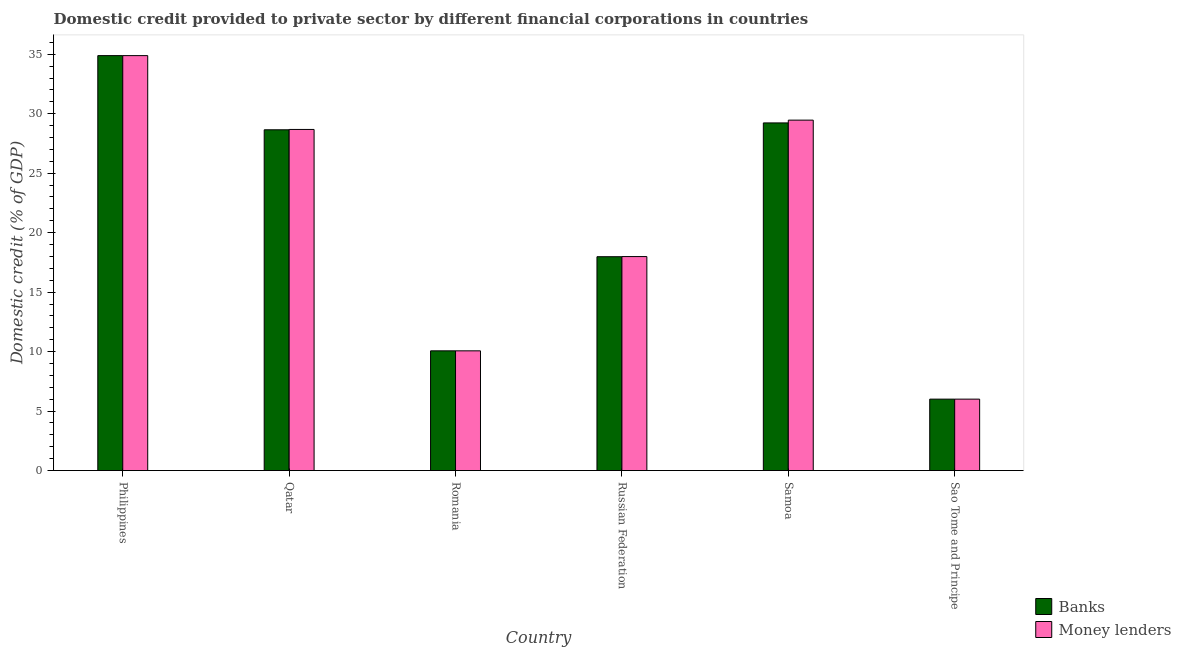What is the label of the 4th group of bars from the left?
Your answer should be compact. Russian Federation. In how many cases, is the number of bars for a given country not equal to the number of legend labels?
Ensure brevity in your answer.  0. What is the domestic credit provided by banks in Philippines?
Keep it short and to the point. 34.88. Across all countries, what is the maximum domestic credit provided by money lenders?
Your answer should be very brief. 34.88. Across all countries, what is the minimum domestic credit provided by banks?
Ensure brevity in your answer.  6.01. In which country was the domestic credit provided by banks maximum?
Make the answer very short. Philippines. In which country was the domestic credit provided by money lenders minimum?
Your answer should be very brief. Sao Tome and Principe. What is the total domestic credit provided by banks in the graph?
Keep it short and to the point. 126.81. What is the difference between the domestic credit provided by money lenders in Samoa and that in Sao Tome and Principe?
Offer a terse response. 23.46. What is the difference between the domestic credit provided by money lenders in Samoa and the domestic credit provided by banks in Romania?
Your answer should be compact. 19.4. What is the average domestic credit provided by banks per country?
Ensure brevity in your answer.  21.14. What is the difference between the domestic credit provided by banks and domestic credit provided by money lenders in Russian Federation?
Your answer should be compact. -0.01. In how many countries, is the domestic credit provided by money lenders greater than 22 %?
Your response must be concise. 3. What is the ratio of the domestic credit provided by money lenders in Philippines to that in Romania?
Your answer should be compact. 3.47. Is the domestic credit provided by money lenders in Philippines less than that in Romania?
Offer a terse response. No. What is the difference between the highest and the second highest domestic credit provided by money lenders?
Provide a short and direct response. 5.42. What is the difference between the highest and the lowest domestic credit provided by banks?
Your answer should be compact. 28.88. In how many countries, is the domestic credit provided by money lenders greater than the average domestic credit provided by money lenders taken over all countries?
Make the answer very short. 3. What does the 2nd bar from the left in Romania represents?
Keep it short and to the point. Money lenders. What does the 1st bar from the right in Russian Federation represents?
Your answer should be very brief. Money lenders. Are all the bars in the graph horizontal?
Provide a short and direct response. No. How many countries are there in the graph?
Your answer should be very brief. 6. What is the difference between two consecutive major ticks on the Y-axis?
Provide a short and direct response. 5. Are the values on the major ticks of Y-axis written in scientific E-notation?
Make the answer very short. No. Does the graph contain any zero values?
Your response must be concise. No. How many legend labels are there?
Keep it short and to the point. 2. How are the legend labels stacked?
Keep it short and to the point. Vertical. What is the title of the graph?
Offer a very short reply. Domestic credit provided to private sector by different financial corporations in countries. Does "Private funds" appear as one of the legend labels in the graph?
Provide a succinct answer. No. What is the label or title of the Y-axis?
Your answer should be compact. Domestic credit (% of GDP). What is the Domestic credit (% of GDP) of Banks in Philippines?
Ensure brevity in your answer.  34.88. What is the Domestic credit (% of GDP) of Money lenders in Philippines?
Your answer should be compact. 34.88. What is the Domestic credit (% of GDP) in Banks in Qatar?
Your response must be concise. 28.65. What is the Domestic credit (% of GDP) of Money lenders in Qatar?
Your answer should be compact. 28.68. What is the Domestic credit (% of GDP) of Banks in Romania?
Offer a terse response. 10.07. What is the Domestic credit (% of GDP) in Money lenders in Romania?
Your response must be concise. 10.07. What is the Domestic credit (% of GDP) in Banks in Russian Federation?
Your response must be concise. 17.98. What is the Domestic credit (% of GDP) of Money lenders in Russian Federation?
Provide a succinct answer. 17.99. What is the Domestic credit (% of GDP) of Banks in Samoa?
Provide a short and direct response. 29.23. What is the Domestic credit (% of GDP) of Money lenders in Samoa?
Offer a very short reply. 29.46. What is the Domestic credit (% of GDP) in Banks in Sao Tome and Principe?
Your answer should be compact. 6.01. What is the Domestic credit (% of GDP) in Money lenders in Sao Tome and Principe?
Give a very brief answer. 6.01. Across all countries, what is the maximum Domestic credit (% of GDP) of Banks?
Ensure brevity in your answer.  34.88. Across all countries, what is the maximum Domestic credit (% of GDP) in Money lenders?
Provide a short and direct response. 34.88. Across all countries, what is the minimum Domestic credit (% of GDP) of Banks?
Your answer should be compact. 6.01. Across all countries, what is the minimum Domestic credit (% of GDP) of Money lenders?
Ensure brevity in your answer.  6.01. What is the total Domestic credit (% of GDP) in Banks in the graph?
Provide a succinct answer. 126.81. What is the total Domestic credit (% of GDP) of Money lenders in the graph?
Give a very brief answer. 127.09. What is the difference between the Domestic credit (% of GDP) of Banks in Philippines and that in Qatar?
Your answer should be very brief. 6.24. What is the difference between the Domestic credit (% of GDP) of Money lenders in Philippines and that in Qatar?
Offer a very short reply. 6.21. What is the difference between the Domestic credit (% of GDP) in Banks in Philippines and that in Romania?
Offer a very short reply. 24.82. What is the difference between the Domestic credit (% of GDP) in Money lenders in Philippines and that in Romania?
Provide a succinct answer. 24.82. What is the difference between the Domestic credit (% of GDP) of Banks in Philippines and that in Russian Federation?
Make the answer very short. 16.91. What is the difference between the Domestic credit (% of GDP) in Money lenders in Philippines and that in Russian Federation?
Provide a succinct answer. 16.89. What is the difference between the Domestic credit (% of GDP) of Banks in Philippines and that in Samoa?
Provide a short and direct response. 5.66. What is the difference between the Domestic credit (% of GDP) in Money lenders in Philippines and that in Samoa?
Make the answer very short. 5.42. What is the difference between the Domestic credit (% of GDP) in Banks in Philippines and that in Sao Tome and Principe?
Give a very brief answer. 28.88. What is the difference between the Domestic credit (% of GDP) in Money lenders in Philippines and that in Sao Tome and Principe?
Your answer should be very brief. 28.88. What is the difference between the Domestic credit (% of GDP) of Banks in Qatar and that in Romania?
Ensure brevity in your answer.  18.58. What is the difference between the Domestic credit (% of GDP) of Money lenders in Qatar and that in Romania?
Your answer should be compact. 18.61. What is the difference between the Domestic credit (% of GDP) of Banks in Qatar and that in Russian Federation?
Keep it short and to the point. 10.67. What is the difference between the Domestic credit (% of GDP) of Money lenders in Qatar and that in Russian Federation?
Offer a terse response. 10.69. What is the difference between the Domestic credit (% of GDP) of Banks in Qatar and that in Samoa?
Your response must be concise. -0.58. What is the difference between the Domestic credit (% of GDP) in Money lenders in Qatar and that in Samoa?
Offer a very short reply. -0.78. What is the difference between the Domestic credit (% of GDP) in Banks in Qatar and that in Sao Tome and Principe?
Give a very brief answer. 22.64. What is the difference between the Domestic credit (% of GDP) in Money lenders in Qatar and that in Sao Tome and Principe?
Your answer should be very brief. 22.67. What is the difference between the Domestic credit (% of GDP) of Banks in Romania and that in Russian Federation?
Make the answer very short. -7.91. What is the difference between the Domestic credit (% of GDP) in Money lenders in Romania and that in Russian Federation?
Offer a terse response. -7.92. What is the difference between the Domestic credit (% of GDP) of Banks in Romania and that in Samoa?
Your answer should be very brief. -19.16. What is the difference between the Domestic credit (% of GDP) of Money lenders in Romania and that in Samoa?
Make the answer very short. -19.4. What is the difference between the Domestic credit (% of GDP) in Banks in Romania and that in Sao Tome and Principe?
Your response must be concise. 4.06. What is the difference between the Domestic credit (% of GDP) in Money lenders in Romania and that in Sao Tome and Principe?
Make the answer very short. 4.06. What is the difference between the Domestic credit (% of GDP) of Banks in Russian Federation and that in Samoa?
Offer a terse response. -11.25. What is the difference between the Domestic credit (% of GDP) in Money lenders in Russian Federation and that in Samoa?
Provide a succinct answer. -11.47. What is the difference between the Domestic credit (% of GDP) in Banks in Russian Federation and that in Sao Tome and Principe?
Provide a succinct answer. 11.97. What is the difference between the Domestic credit (% of GDP) of Money lenders in Russian Federation and that in Sao Tome and Principe?
Make the answer very short. 11.99. What is the difference between the Domestic credit (% of GDP) in Banks in Samoa and that in Sao Tome and Principe?
Give a very brief answer. 23.22. What is the difference between the Domestic credit (% of GDP) of Money lenders in Samoa and that in Sao Tome and Principe?
Offer a terse response. 23.46. What is the difference between the Domestic credit (% of GDP) of Banks in Philippines and the Domestic credit (% of GDP) of Money lenders in Qatar?
Your answer should be very brief. 6.21. What is the difference between the Domestic credit (% of GDP) in Banks in Philippines and the Domestic credit (% of GDP) in Money lenders in Romania?
Make the answer very short. 24.82. What is the difference between the Domestic credit (% of GDP) in Banks in Philippines and the Domestic credit (% of GDP) in Money lenders in Russian Federation?
Your answer should be compact. 16.89. What is the difference between the Domestic credit (% of GDP) of Banks in Philippines and the Domestic credit (% of GDP) of Money lenders in Samoa?
Provide a short and direct response. 5.42. What is the difference between the Domestic credit (% of GDP) of Banks in Philippines and the Domestic credit (% of GDP) of Money lenders in Sao Tome and Principe?
Provide a succinct answer. 28.88. What is the difference between the Domestic credit (% of GDP) in Banks in Qatar and the Domestic credit (% of GDP) in Money lenders in Romania?
Offer a very short reply. 18.58. What is the difference between the Domestic credit (% of GDP) of Banks in Qatar and the Domestic credit (% of GDP) of Money lenders in Russian Federation?
Your response must be concise. 10.66. What is the difference between the Domestic credit (% of GDP) of Banks in Qatar and the Domestic credit (% of GDP) of Money lenders in Samoa?
Your response must be concise. -0.81. What is the difference between the Domestic credit (% of GDP) in Banks in Qatar and the Domestic credit (% of GDP) in Money lenders in Sao Tome and Principe?
Provide a succinct answer. 22.64. What is the difference between the Domestic credit (% of GDP) of Banks in Romania and the Domestic credit (% of GDP) of Money lenders in Russian Federation?
Your answer should be very brief. -7.92. What is the difference between the Domestic credit (% of GDP) of Banks in Romania and the Domestic credit (% of GDP) of Money lenders in Samoa?
Make the answer very short. -19.4. What is the difference between the Domestic credit (% of GDP) of Banks in Romania and the Domestic credit (% of GDP) of Money lenders in Sao Tome and Principe?
Make the answer very short. 4.06. What is the difference between the Domestic credit (% of GDP) in Banks in Russian Federation and the Domestic credit (% of GDP) in Money lenders in Samoa?
Offer a terse response. -11.48. What is the difference between the Domestic credit (% of GDP) of Banks in Russian Federation and the Domestic credit (% of GDP) of Money lenders in Sao Tome and Principe?
Your response must be concise. 11.97. What is the difference between the Domestic credit (% of GDP) in Banks in Samoa and the Domestic credit (% of GDP) in Money lenders in Sao Tome and Principe?
Make the answer very short. 23.22. What is the average Domestic credit (% of GDP) in Banks per country?
Your answer should be compact. 21.14. What is the average Domestic credit (% of GDP) of Money lenders per country?
Your response must be concise. 21.18. What is the difference between the Domestic credit (% of GDP) of Banks and Domestic credit (% of GDP) of Money lenders in Qatar?
Keep it short and to the point. -0.03. What is the difference between the Domestic credit (% of GDP) in Banks and Domestic credit (% of GDP) in Money lenders in Russian Federation?
Make the answer very short. -0.01. What is the difference between the Domestic credit (% of GDP) of Banks and Domestic credit (% of GDP) of Money lenders in Samoa?
Provide a short and direct response. -0.23. What is the difference between the Domestic credit (% of GDP) in Banks and Domestic credit (% of GDP) in Money lenders in Sao Tome and Principe?
Keep it short and to the point. 0. What is the ratio of the Domestic credit (% of GDP) in Banks in Philippines to that in Qatar?
Give a very brief answer. 1.22. What is the ratio of the Domestic credit (% of GDP) in Money lenders in Philippines to that in Qatar?
Your answer should be compact. 1.22. What is the ratio of the Domestic credit (% of GDP) of Banks in Philippines to that in Romania?
Your response must be concise. 3.47. What is the ratio of the Domestic credit (% of GDP) in Money lenders in Philippines to that in Romania?
Your answer should be compact. 3.47. What is the ratio of the Domestic credit (% of GDP) of Banks in Philippines to that in Russian Federation?
Offer a terse response. 1.94. What is the ratio of the Domestic credit (% of GDP) in Money lenders in Philippines to that in Russian Federation?
Your answer should be compact. 1.94. What is the ratio of the Domestic credit (% of GDP) of Banks in Philippines to that in Samoa?
Provide a short and direct response. 1.19. What is the ratio of the Domestic credit (% of GDP) in Money lenders in Philippines to that in Samoa?
Offer a very short reply. 1.18. What is the ratio of the Domestic credit (% of GDP) in Banks in Philippines to that in Sao Tome and Principe?
Your response must be concise. 5.81. What is the ratio of the Domestic credit (% of GDP) in Money lenders in Philippines to that in Sao Tome and Principe?
Provide a short and direct response. 5.81. What is the ratio of the Domestic credit (% of GDP) of Banks in Qatar to that in Romania?
Make the answer very short. 2.85. What is the ratio of the Domestic credit (% of GDP) in Money lenders in Qatar to that in Romania?
Keep it short and to the point. 2.85. What is the ratio of the Domestic credit (% of GDP) of Banks in Qatar to that in Russian Federation?
Ensure brevity in your answer.  1.59. What is the ratio of the Domestic credit (% of GDP) in Money lenders in Qatar to that in Russian Federation?
Make the answer very short. 1.59. What is the ratio of the Domestic credit (% of GDP) in Banks in Qatar to that in Samoa?
Ensure brevity in your answer.  0.98. What is the ratio of the Domestic credit (% of GDP) of Money lenders in Qatar to that in Samoa?
Offer a very short reply. 0.97. What is the ratio of the Domestic credit (% of GDP) in Banks in Qatar to that in Sao Tome and Principe?
Your answer should be compact. 4.77. What is the ratio of the Domestic credit (% of GDP) of Money lenders in Qatar to that in Sao Tome and Principe?
Ensure brevity in your answer.  4.78. What is the ratio of the Domestic credit (% of GDP) of Banks in Romania to that in Russian Federation?
Your response must be concise. 0.56. What is the ratio of the Domestic credit (% of GDP) of Money lenders in Romania to that in Russian Federation?
Keep it short and to the point. 0.56. What is the ratio of the Domestic credit (% of GDP) of Banks in Romania to that in Samoa?
Your response must be concise. 0.34. What is the ratio of the Domestic credit (% of GDP) in Money lenders in Romania to that in Samoa?
Provide a succinct answer. 0.34. What is the ratio of the Domestic credit (% of GDP) in Banks in Romania to that in Sao Tome and Principe?
Ensure brevity in your answer.  1.68. What is the ratio of the Domestic credit (% of GDP) in Money lenders in Romania to that in Sao Tome and Principe?
Give a very brief answer. 1.68. What is the ratio of the Domestic credit (% of GDP) of Banks in Russian Federation to that in Samoa?
Provide a short and direct response. 0.62. What is the ratio of the Domestic credit (% of GDP) in Money lenders in Russian Federation to that in Samoa?
Ensure brevity in your answer.  0.61. What is the ratio of the Domestic credit (% of GDP) in Banks in Russian Federation to that in Sao Tome and Principe?
Your response must be concise. 2.99. What is the ratio of the Domestic credit (% of GDP) of Money lenders in Russian Federation to that in Sao Tome and Principe?
Offer a terse response. 3. What is the ratio of the Domestic credit (% of GDP) in Banks in Samoa to that in Sao Tome and Principe?
Keep it short and to the point. 4.87. What is the ratio of the Domestic credit (% of GDP) in Money lenders in Samoa to that in Sao Tome and Principe?
Your answer should be compact. 4.91. What is the difference between the highest and the second highest Domestic credit (% of GDP) in Banks?
Provide a short and direct response. 5.66. What is the difference between the highest and the second highest Domestic credit (% of GDP) of Money lenders?
Offer a very short reply. 5.42. What is the difference between the highest and the lowest Domestic credit (% of GDP) in Banks?
Provide a short and direct response. 28.88. What is the difference between the highest and the lowest Domestic credit (% of GDP) in Money lenders?
Your answer should be very brief. 28.88. 